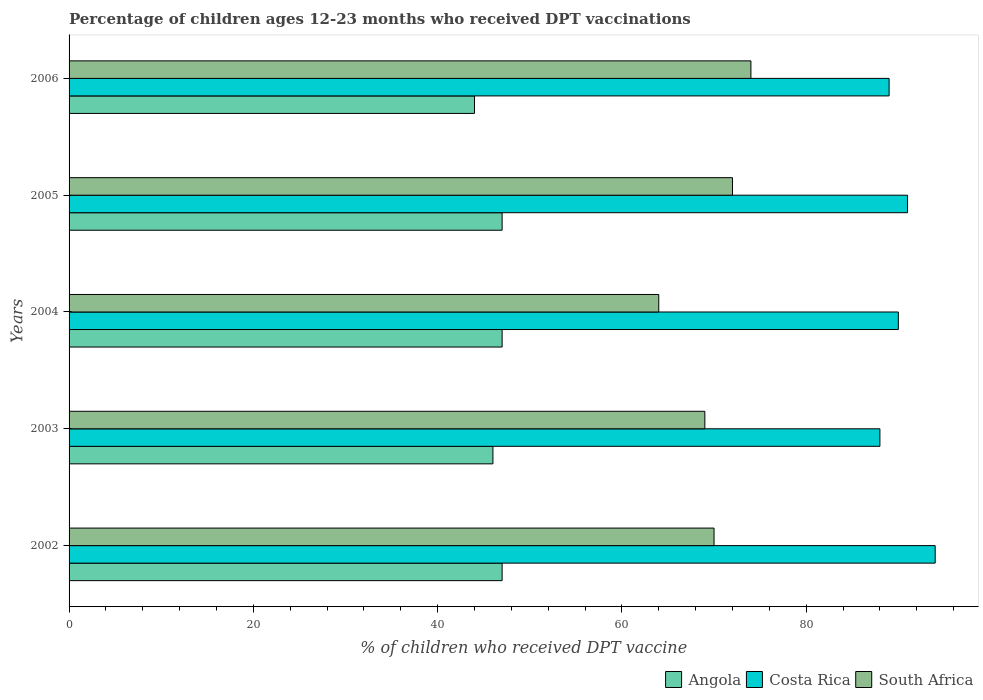How many different coloured bars are there?
Provide a succinct answer. 3. How many groups of bars are there?
Your response must be concise. 5. What is the label of the 5th group of bars from the top?
Give a very brief answer. 2002. In how many cases, is the number of bars for a given year not equal to the number of legend labels?
Provide a succinct answer. 0. What is the percentage of children who received DPT vaccination in Angola in 2006?
Offer a terse response. 44. Across all years, what is the maximum percentage of children who received DPT vaccination in Costa Rica?
Your answer should be compact. 94. Across all years, what is the minimum percentage of children who received DPT vaccination in Angola?
Your answer should be compact. 44. What is the total percentage of children who received DPT vaccination in Costa Rica in the graph?
Your answer should be very brief. 452. What is the difference between the percentage of children who received DPT vaccination in South Africa in 2003 and that in 2006?
Offer a terse response. -5. What is the difference between the percentage of children who received DPT vaccination in Angola in 2006 and the percentage of children who received DPT vaccination in Costa Rica in 2002?
Your answer should be compact. -50. What is the average percentage of children who received DPT vaccination in Costa Rica per year?
Ensure brevity in your answer.  90.4. In the year 2002, what is the difference between the percentage of children who received DPT vaccination in Angola and percentage of children who received DPT vaccination in Costa Rica?
Offer a terse response. -47. In how many years, is the percentage of children who received DPT vaccination in Angola greater than 44 %?
Offer a terse response. 4. What is the ratio of the percentage of children who received DPT vaccination in South Africa in 2004 to that in 2006?
Your answer should be very brief. 0.86. Is the percentage of children who received DPT vaccination in South Africa in 2004 less than that in 2005?
Make the answer very short. Yes. What is the difference between the highest and the lowest percentage of children who received DPT vaccination in South Africa?
Provide a succinct answer. 10. In how many years, is the percentage of children who received DPT vaccination in Angola greater than the average percentage of children who received DPT vaccination in Angola taken over all years?
Make the answer very short. 3. Is the sum of the percentage of children who received DPT vaccination in South Africa in 2003 and 2005 greater than the maximum percentage of children who received DPT vaccination in Costa Rica across all years?
Offer a terse response. Yes. What does the 1st bar from the top in 2006 represents?
Give a very brief answer. South Africa. What does the 3rd bar from the bottom in 2003 represents?
Make the answer very short. South Africa. How many bars are there?
Your answer should be very brief. 15. Are all the bars in the graph horizontal?
Ensure brevity in your answer.  Yes. What is the difference between two consecutive major ticks on the X-axis?
Ensure brevity in your answer.  20. Are the values on the major ticks of X-axis written in scientific E-notation?
Provide a short and direct response. No. Does the graph contain any zero values?
Your answer should be compact. No. Does the graph contain grids?
Your answer should be compact. No. Where does the legend appear in the graph?
Offer a terse response. Bottom right. How many legend labels are there?
Make the answer very short. 3. How are the legend labels stacked?
Give a very brief answer. Horizontal. What is the title of the graph?
Offer a terse response. Percentage of children ages 12-23 months who received DPT vaccinations. Does "Latvia" appear as one of the legend labels in the graph?
Give a very brief answer. No. What is the label or title of the X-axis?
Provide a succinct answer. % of children who received DPT vaccine. What is the % of children who received DPT vaccine in Costa Rica in 2002?
Your answer should be very brief. 94. What is the % of children who received DPT vaccine in South Africa in 2002?
Ensure brevity in your answer.  70. What is the % of children who received DPT vaccine of Costa Rica in 2003?
Keep it short and to the point. 88. What is the % of children who received DPT vaccine in Angola in 2004?
Your answer should be very brief. 47. What is the % of children who received DPT vaccine in Costa Rica in 2004?
Offer a terse response. 90. What is the % of children who received DPT vaccine of South Africa in 2004?
Your response must be concise. 64. What is the % of children who received DPT vaccine in Costa Rica in 2005?
Provide a short and direct response. 91. What is the % of children who received DPT vaccine in South Africa in 2005?
Provide a succinct answer. 72. What is the % of children who received DPT vaccine of Costa Rica in 2006?
Offer a very short reply. 89. Across all years, what is the maximum % of children who received DPT vaccine of Angola?
Give a very brief answer. 47. Across all years, what is the maximum % of children who received DPT vaccine in Costa Rica?
Your answer should be very brief. 94. Across all years, what is the minimum % of children who received DPT vaccine of Angola?
Your answer should be compact. 44. Across all years, what is the minimum % of children who received DPT vaccine of Costa Rica?
Keep it short and to the point. 88. Across all years, what is the minimum % of children who received DPT vaccine of South Africa?
Your answer should be very brief. 64. What is the total % of children who received DPT vaccine of Angola in the graph?
Give a very brief answer. 231. What is the total % of children who received DPT vaccine of Costa Rica in the graph?
Keep it short and to the point. 452. What is the total % of children who received DPT vaccine of South Africa in the graph?
Provide a short and direct response. 349. What is the difference between the % of children who received DPT vaccine of Angola in 2002 and that in 2003?
Give a very brief answer. 1. What is the difference between the % of children who received DPT vaccine of South Africa in 2002 and that in 2003?
Provide a succinct answer. 1. What is the difference between the % of children who received DPT vaccine in Costa Rica in 2002 and that in 2004?
Provide a short and direct response. 4. What is the difference between the % of children who received DPT vaccine in South Africa in 2002 and that in 2004?
Your response must be concise. 6. What is the difference between the % of children who received DPT vaccine of South Africa in 2002 and that in 2005?
Give a very brief answer. -2. What is the difference between the % of children who received DPT vaccine in Angola in 2002 and that in 2006?
Your answer should be compact. 3. What is the difference between the % of children who received DPT vaccine in Costa Rica in 2002 and that in 2006?
Provide a short and direct response. 5. What is the difference between the % of children who received DPT vaccine of Angola in 2003 and that in 2004?
Provide a short and direct response. -1. What is the difference between the % of children who received DPT vaccine of Costa Rica in 2003 and that in 2004?
Give a very brief answer. -2. What is the difference between the % of children who received DPT vaccine in Angola in 2003 and that in 2005?
Your response must be concise. -1. What is the difference between the % of children who received DPT vaccine in Costa Rica in 2003 and that in 2005?
Provide a succinct answer. -3. What is the difference between the % of children who received DPT vaccine in South Africa in 2003 and that in 2005?
Make the answer very short. -3. What is the difference between the % of children who received DPT vaccine of South Africa in 2003 and that in 2006?
Offer a very short reply. -5. What is the difference between the % of children who received DPT vaccine of Angola in 2004 and that in 2005?
Your response must be concise. 0. What is the difference between the % of children who received DPT vaccine in Angola in 2004 and that in 2006?
Offer a very short reply. 3. What is the difference between the % of children who received DPT vaccine in Costa Rica in 2004 and that in 2006?
Offer a very short reply. 1. What is the difference between the % of children who received DPT vaccine of Costa Rica in 2005 and that in 2006?
Your answer should be very brief. 2. What is the difference between the % of children who received DPT vaccine of South Africa in 2005 and that in 2006?
Offer a terse response. -2. What is the difference between the % of children who received DPT vaccine of Angola in 2002 and the % of children who received DPT vaccine of Costa Rica in 2003?
Offer a very short reply. -41. What is the difference between the % of children who received DPT vaccine in Costa Rica in 2002 and the % of children who received DPT vaccine in South Africa in 2003?
Ensure brevity in your answer.  25. What is the difference between the % of children who received DPT vaccine in Angola in 2002 and the % of children who received DPT vaccine in Costa Rica in 2004?
Your response must be concise. -43. What is the difference between the % of children who received DPT vaccine in Angola in 2002 and the % of children who received DPT vaccine in South Africa in 2004?
Give a very brief answer. -17. What is the difference between the % of children who received DPT vaccine in Costa Rica in 2002 and the % of children who received DPT vaccine in South Africa in 2004?
Make the answer very short. 30. What is the difference between the % of children who received DPT vaccine in Angola in 2002 and the % of children who received DPT vaccine in Costa Rica in 2005?
Give a very brief answer. -44. What is the difference between the % of children who received DPT vaccine in Angola in 2002 and the % of children who received DPT vaccine in South Africa in 2005?
Ensure brevity in your answer.  -25. What is the difference between the % of children who received DPT vaccine in Angola in 2002 and the % of children who received DPT vaccine in Costa Rica in 2006?
Provide a short and direct response. -42. What is the difference between the % of children who received DPT vaccine of Costa Rica in 2002 and the % of children who received DPT vaccine of South Africa in 2006?
Make the answer very short. 20. What is the difference between the % of children who received DPT vaccine of Angola in 2003 and the % of children who received DPT vaccine of Costa Rica in 2004?
Provide a short and direct response. -44. What is the difference between the % of children who received DPT vaccine of Angola in 2003 and the % of children who received DPT vaccine of South Africa in 2004?
Provide a short and direct response. -18. What is the difference between the % of children who received DPT vaccine in Costa Rica in 2003 and the % of children who received DPT vaccine in South Africa in 2004?
Provide a short and direct response. 24. What is the difference between the % of children who received DPT vaccine in Angola in 2003 and the % of children who received DPT vaccine in Costa Rica in 2005?
Provide a succinct answer. -45. What is the difference between the % of children who received DPT vaccine of Angola in 2003 and the % of children who received DPT vaccine of South Africa in 2005?
Provide a short and direct response. -26. What is the difference between the % of children who received DPT vaccine in Angola in 2003 and the % of children who received DPT vaccine in Costa Rica in 2006?
Offer a terse response. -43. What is the difference between the % of children who received DPT vaccine in Angola in 2003 and the % of children who received DPT vaccine in South Africa in 2006?
Provide a short and direct response. -28. What is the difference between the % of children who received DPT vaccine of Angola in 2004 and the % of children who received DPT vaccine of Costa Rica in 2005?
Keep it short and to the point. -44. What is the difference between the % of children who received DPT vaccine of Angola in 2004 and the % of children who received DPT vaccine of Costa Rica in 2006?
Your answer should be very brief. -42. What is the difference between the % of children who received DPT vaccine in Costa Rica in 2004 and the % of children who received DPT vaccine in South Africa in 2006?
Your answer should be very brief. 16. What is the difference between the % of children who received DPT vaccine in Angola in 2005 and the % of children who received DPT vaccine in Costa Rica in 2006?
Your answer should be compact. -42. What is the difference between the % of children who received DPT vaccine of Costa Rica in 2005 and the % of children who received DPT vaccine of South Africa in 2006?
Provide a succinct answer. 17. What is the average % of children who received DPT vaccine in Angola per year?
Make the answer very short. 46.2. What is the average % of children who received DPT vaccine in Costa Rica per year?
Your answer should be compact. 90.4. What is the average % of children who received DPT vaccine of South Africa per year?
Keep it short and to the point. 69.8. In the year 2002, what is the difference between the % of children who received DPT vaccine in Angola and % of children who received DPT vaccine in Costa Rica?
Give a very brief answer. -47. In the year 2002, what is the difference between the % of children who received DPT vaccine of Costa Rica and % of children who received DPT vaccine of South Africa?
Offer a terse response. 24. In the year 2003, what is the difference between the % of children who received DPT vaccine in Angola and % of children who received DPT vaccine in Costa Rica?
Your answer should be compact. -42. In the year 2003, what is the difference between the % of children who received DPT vaccine of Costa Rica and % of children who received DPT vaccine of South Africa?
Ensure brevity in your answer.  19. In the year 2004, what is the difference between the % of children who received DPT vaccine of Angola and % of children who received DPT vaccine of Costa Rica?
Provide a short and direct response. -43. In the year 2004, what is the difference between the % of children who received DPT vaccine in Angola and % of children who received DPT vaccine in South Africa?
Offer a very short reply. -17. In the year 2004, what is the difference between the % of children who received DPT vaccine of Costa Rica and % of children who received DPT vaccine of South Africa?
Your answer should be compact. 26. In the year 2005, what is the difference between the % of children who received DPT vaccine of Angola and % of children who received DPT vaccine of Costa Rica?
Provide a succinct answer. -44. In the year 2005, what is the difference between the % of children who received DPT vaccine of Costa Rica and % of children who received DPT vaccine of South Africa?
Keep it short and to the point. 19. In the year 2006, what is the difference between the % of children who received DPT vaccine in Angola and % of children who received DPT vaccine in Costa Rica?
Offer a very short reply. -45. In the year 2006, what is the difference between the % of children who received DPT vaccine in Costa Rica and % of children who received DPT vaccine in South Africa?
Provide a short and direct response. 15. What is the ratio of the % of children who received DPT vaccine in Angola in 2002 to that in 2003?
Offer a very short reply. 1.02. What is the ratio of the % of children who received DPT vaccine of Costa Rica in 2002 to that in 2003?
Offer a very short reply. 1.07. What is the ratio of the % of children who received DPT vaccine in South Africa in 2002 to that in 2003?
Your response must be concise. 1.01. What is the ratio of the % of children who received DPT vaccine in Angola in 2002 to that in 2004?
Your response must be concise. 1. What is the ratio of the % of children who received DPT vaccine of Costa Rica in 2002 to that in 2004?
Give a very brief answer. 1.04. What is the ratio of the % of children who received DPT vaccine of South Africa in 2002 to that in 2004?
Your answer should be very brief. 1.09. What is the ratio of the % of children who received DPT vaccine in Angola in 2002 to that in 2005?
Provide a succinct answer. 1. What is the ratio of the % of children who received DPT vaccine in Costa Rica in 2002 to that in 2005?
Offer a very short reply. 1.03. What is the ratio of the % of children who received DPT vaccine in South Africa in 2002 to that in 2005?
Provide a short and direct response. 0.97. What is the ratio of the % of children who received DPT vaccine in Angola in 2002 to that in 2006?
Ensure brevity in your answer.  1.07. What is the ratio of the % of children who received DPT vaccine of Costa Rica in 2002 to that in 2006?
Provide a short and direct response. 1.06. What is the ratio of the % of children who received DPT vaccine in South Africa in 2002 to that in 2006?
Keep it short and to the point. 0.95. What is the ratio of the % of children who received DPT vaccine of Angola in 2003 to that in 2004?
Your answer should be very brief. 0.98. What is the ratio of the % of children who received DPT vaccine of Costa Rica in 2003 to that in 2004?
Give a very brief answer. 0.98. What is the ratio of the % of children who received DPT vaccine in South Africa in 2003 to that in 2004?
Offer a very short reply. 1.08. What is the ratio of the % of children who received DPT vaccine of Angola in 2003 to that in 2005?
Ensure brevity in your answer.  0.98. What is the ratio of the % of children who received DPT vaccine in Angola in 2003 to that in 2006?
Offer a very short reply. 1.05. What is the ratio of the % of children who received DPT vaccine of South Africa in 2003 to that in 2006?
Provide a short and direct response. 0.93. What is the ratio of the % of children who received DPT vaccine of Angola in 2004 to that in 2006?
Your response must be concise. 1.07. What is the ratio of the % of children who received DPT vaccine of Costa Rica in 2004 to that in 2006?
Keep it short and to the point. 1.01. What is the ratio of the % of children who received DPT vaccine of South Africa in 2004 to that in 2006?
Your answer should be very brief. 0.86. What is the ratio of the % of children who received DPT vaccine in Angola in 2005 to that in 2006?
Ensure brevity in your answer.  1.07. What is the ratio of the % of children who received DPT vaccine of Costa Rica in 2005 to that in 2006?
Keep it short and to the point. 1.02. What is the difference between the highest and the second highest % of children who received DPT vaccine in Angola?
Provide a short and direct response. 0. What is the difference between the highest and the second highest % of children who received DPT vaccine in Costa Rica?
Provide a succinct answer. 3. What is the difference between the highest and the second highest % of children who received DPT vaccine in South Africa?
Offer a very short reply. 2. 